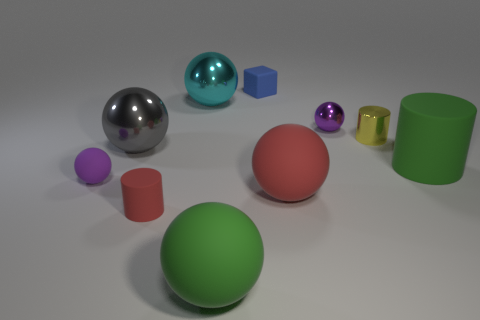Subtract all gray spheres. How many spheres are left? 5 Subtract all small shiny spheres. How many spheres are left? 5 Subtract 1 spheres. How many spheres are left? 5 Subtract all red balls. Subtract all red blocks. How many balls are left? 5 Subtract all spheres. How many objects are left? 4 Add 1 small objects. How many small objects are left? 6 Add 2 small green rubber cubes. How many small green rubber cubes exist? 2 Subtract 1 green cylinders. How many objects are left? 9 Subtract all small gray rubber spheres. Subtract all big green balls. How many objects are left? 9 